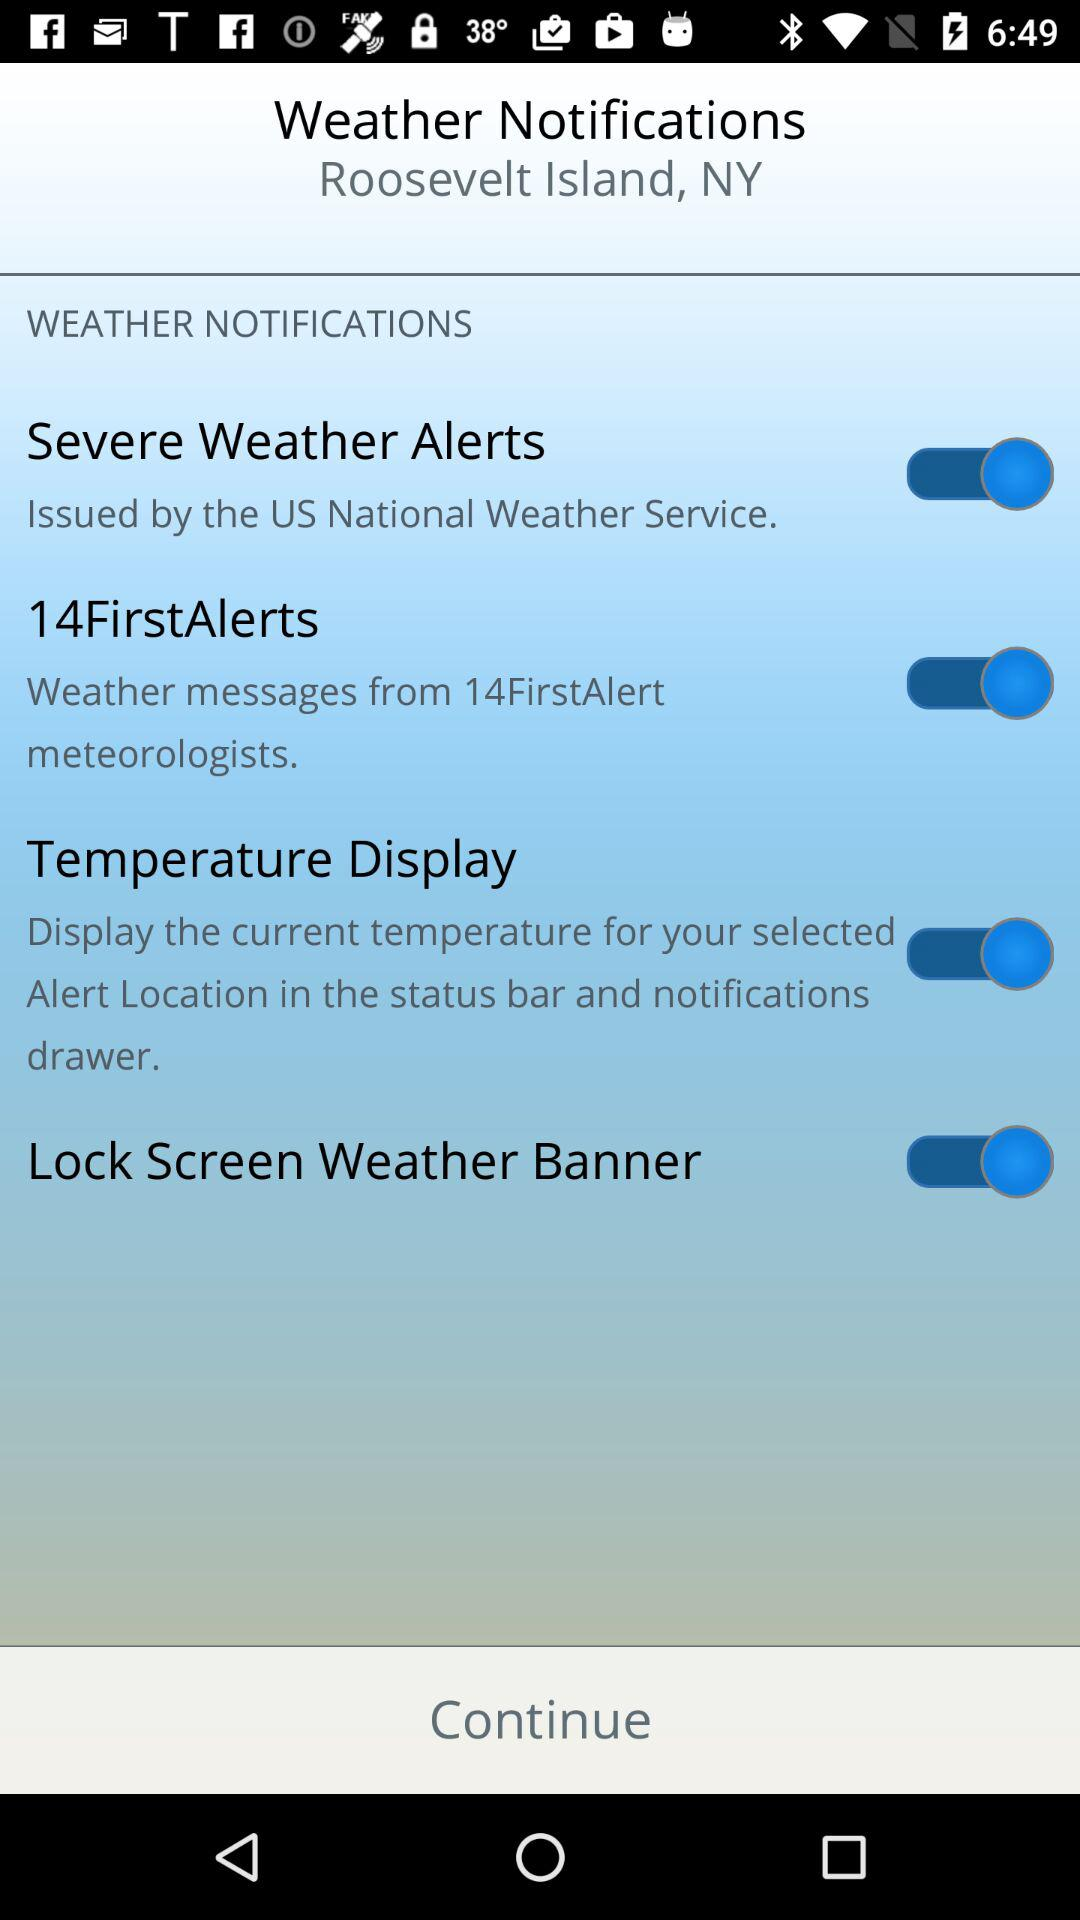What is the mentioned location? The location is Roosevelt Island, NY. 